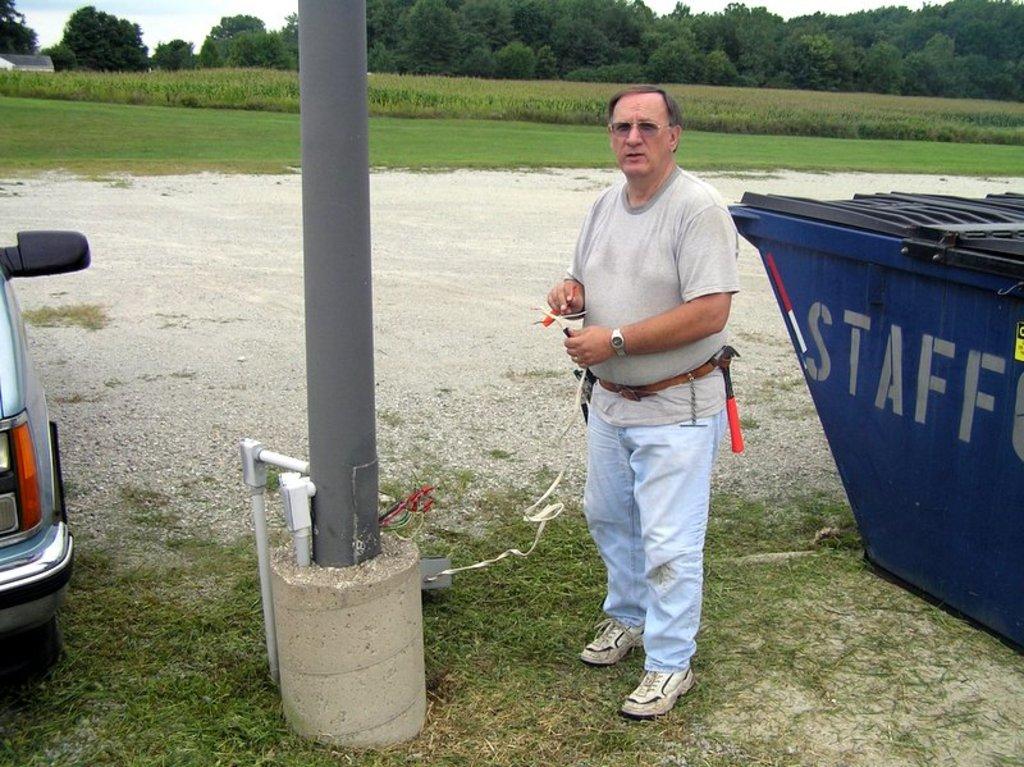What is the blue bin for?
Provide a short and direct response. Staff. 